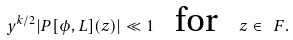Convert formula to latex. <formula><loc_0><loc_0><loc_500><loc_500>y ^ { k / 2 } | P [ \phi , L ] ( z ) | \ll 1 \text { \ \ for \ \ } z \in \ F .</formula> 